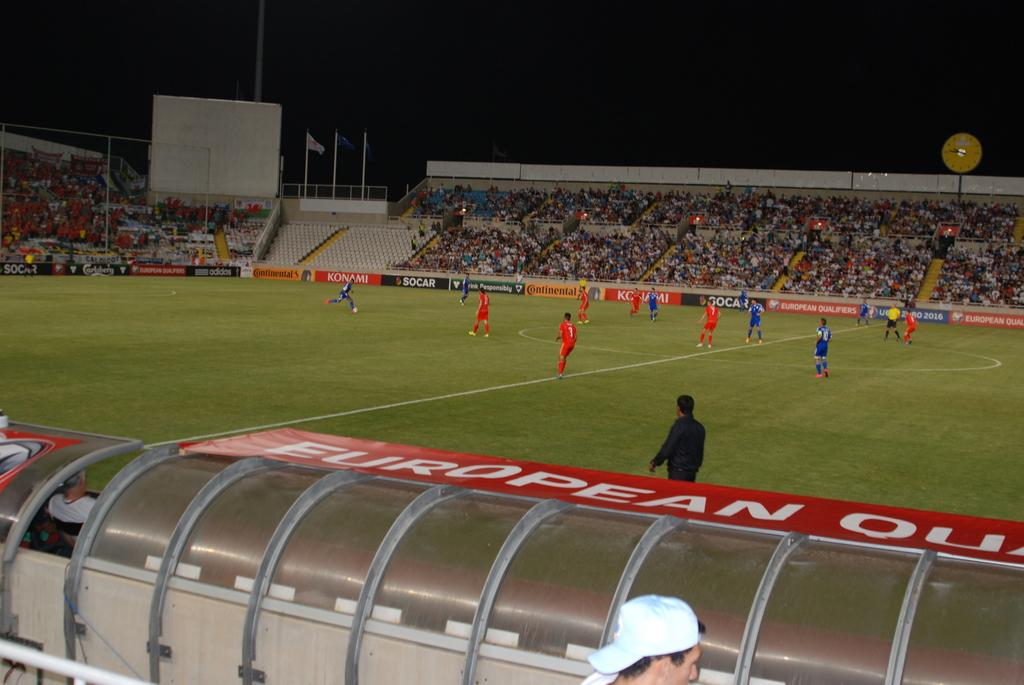<image>
Create a compact narrative representing the image presented. The walls of a soccer stadium contain ads for Konami and Adidias, plus many more. 